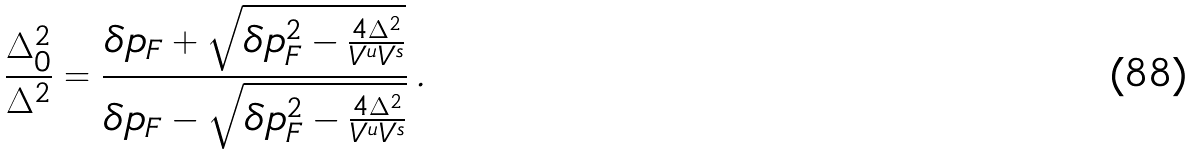Convert formula to latex. <formula><loc_0><loc_0><loc_500><loc_500>\frac { \Delta _ { 0 } ^ { 2 } } { \Delta ^ { 2 } } = \frac { \delta p _ { F } + \sqrt { \delta p _ { F } ^ { 2 } - \frac { 4 \Delta ^ { 2 } } { V ^ { u } V ^ { s } } } } { \delta p _ { F } - \sqrt { \delta p _ { F } ^ { 2 } - \frac { 4 \Delta ^ { 2 } } { V ^ { u } V ^ { s } } } } \, .</formula> 